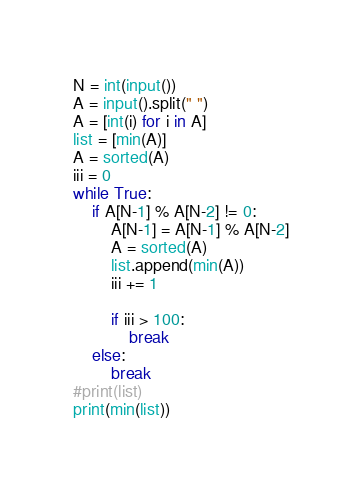Convert code to text. <code><loc_0><loc_0><loc_500><loc_500><_Python_>N = int(input())
A = input().split(" ")
A = [int(i) for i in A]
list = [min(A)]
A = sorted(A)
iii = 0
while True:
    if A[N-1] % A[N-2] != 0:
        A[N-1] = A[N-1] % A[N-2]
        A = sorted(A)
        list.append(min(A))
        iii += 1
        
        if iii > 100:
            break
    else:
        break
#print(list)
print(min(list))</code> 